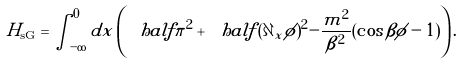Convert formula to latex. <formula><loc_0><loc_0><loc_500><loc_500>H _ { \text {sG} } = \int _ { - \infty } ^ { 0 } d x \left ( \ h a l f \pi ^ { 2 } + \ h a l f ( \partial _ { x } \phi ) ^ { 2 } - \frac { m ^ { 2 } } { \beta ^ { 2 } } ( \cos \beta \phi - 1 ) \right ) .</formula> 